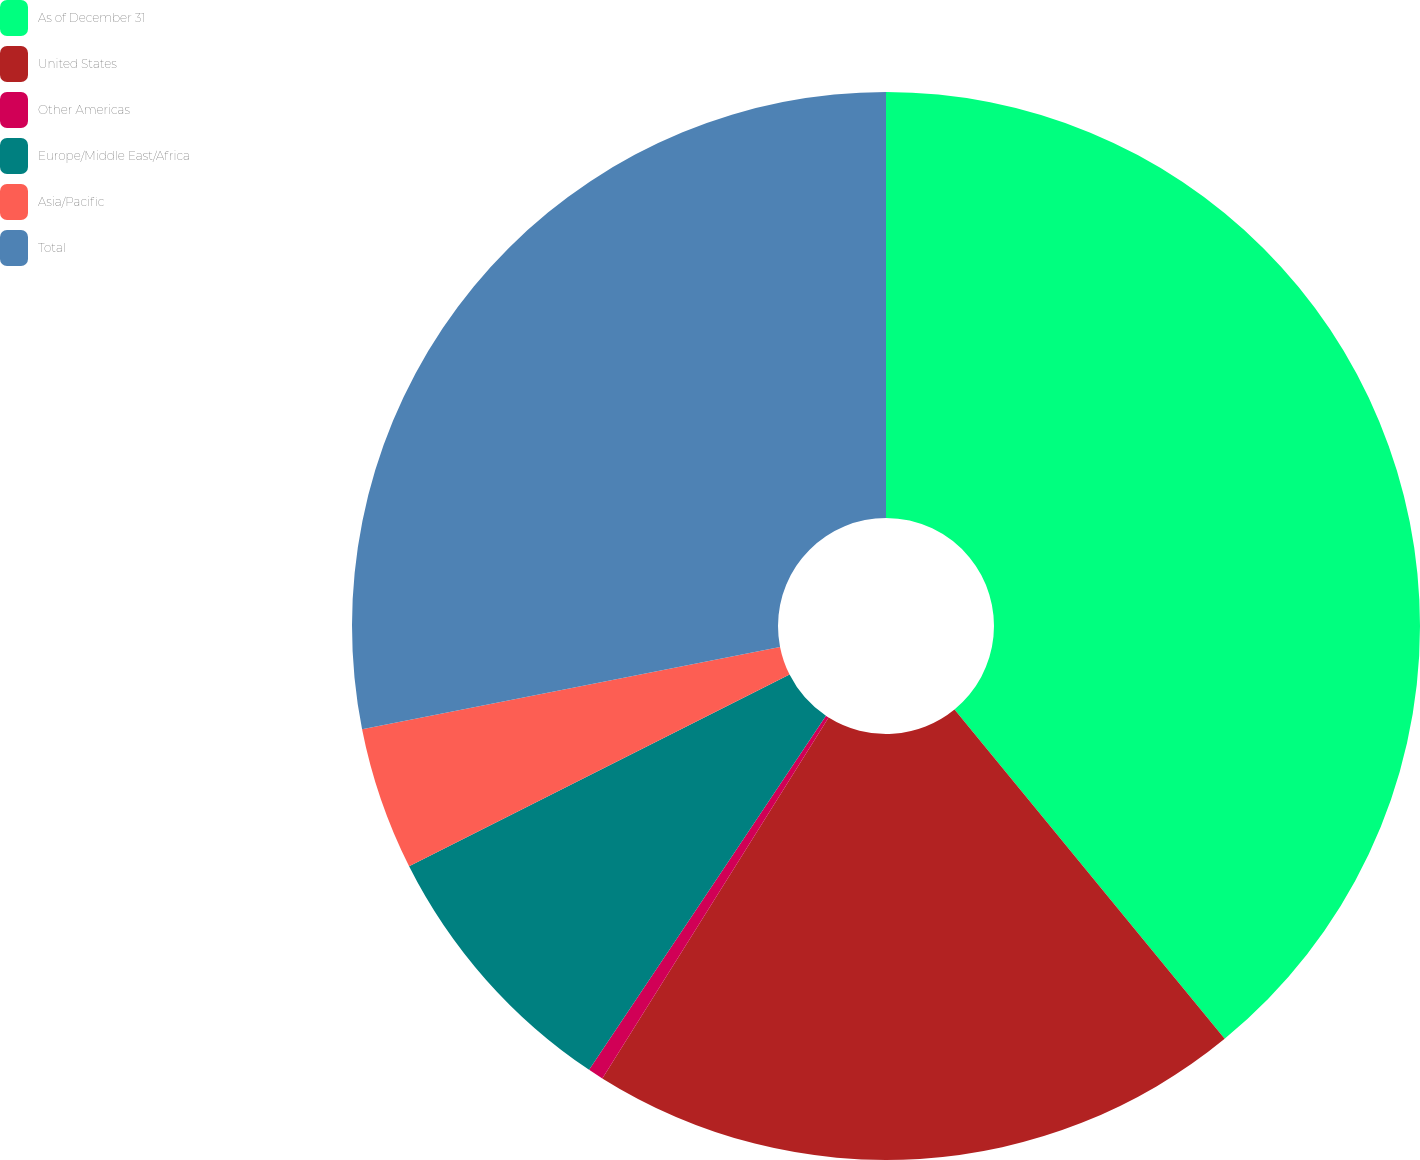Convert chart to OTSL. <chart><loc_0><loc_0><loc_500><loc_500><pie_chart><fcel>As of December 31<fcel>United States<fcel>Other Americas<fcel>Europe/Middle East/Africa<fcel>Asia/Pacific<fcel>Total<nl><fcel>39.07%<fcel>19.85%<fcel>0.47%<fcel>8.19%<fcel>4.33%<fcel>28.1%<nl></chart> 